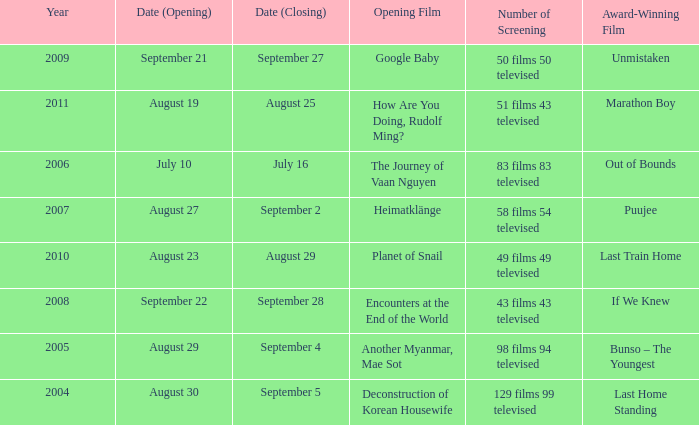Which award-winning film has a screening number of 50 films 50 televised? Unmistaken. 